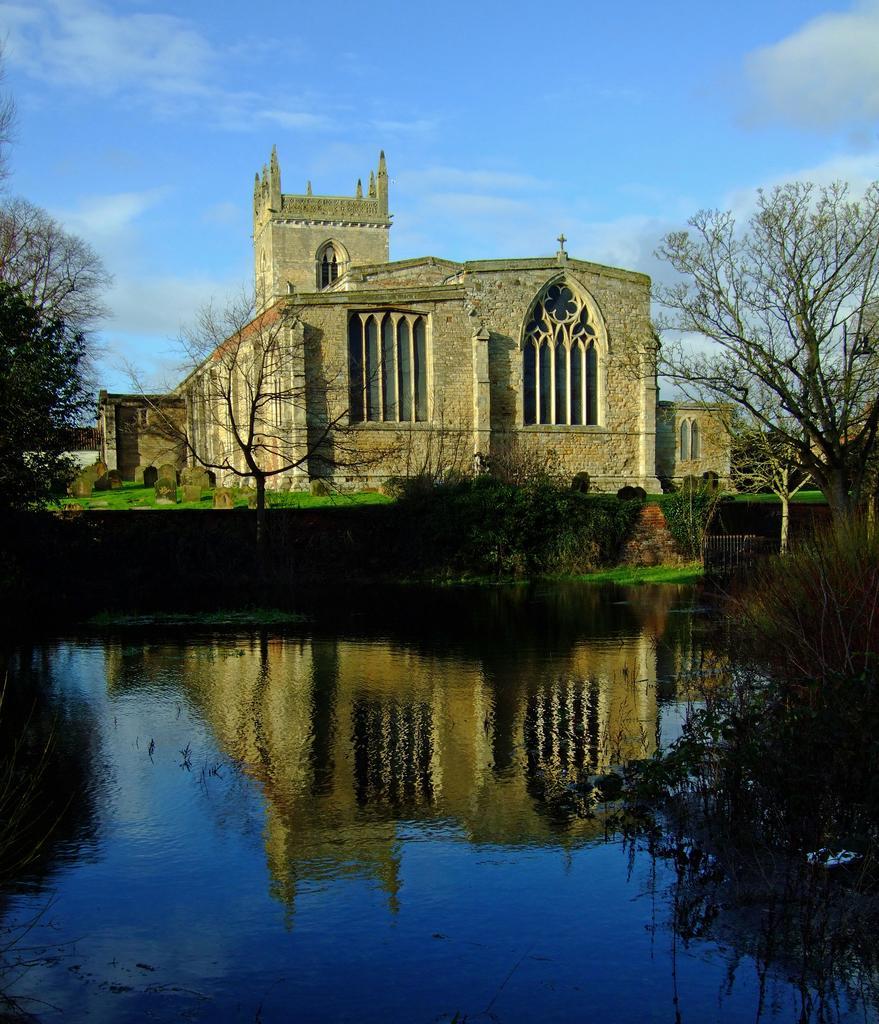Describe this image in one or two sentences. This picture shows a building and we see few trees and water and we see a cloudy Sky. 